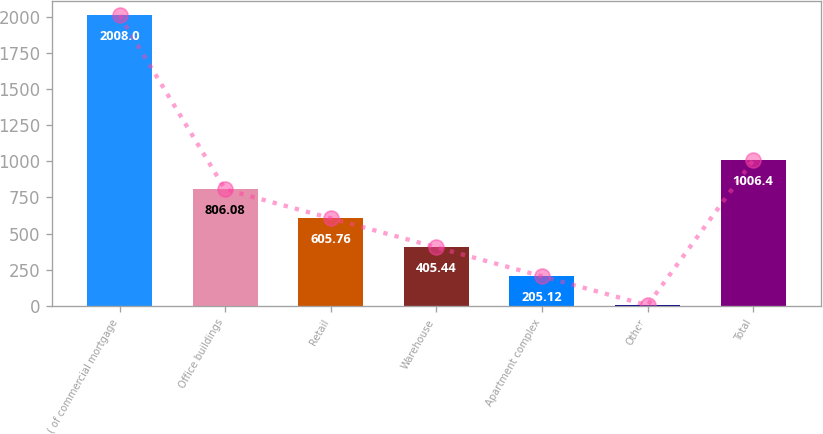Convert chart. <chart><loc_0><loc_0><loc_500><loc_500><bar_chart><fcel>( of commercial mortgage<fcel>Office buildings<fcel>Retail<fcel>Warehouse<fcel>Apartment complex<fcel>Other<fcel>Total<nl><fcel>2008<fcel>806.08<fcel>605.76<fcel>405.44<fcel>205.12<fcel>4.8<fcel>1006.4<nl></chart> 